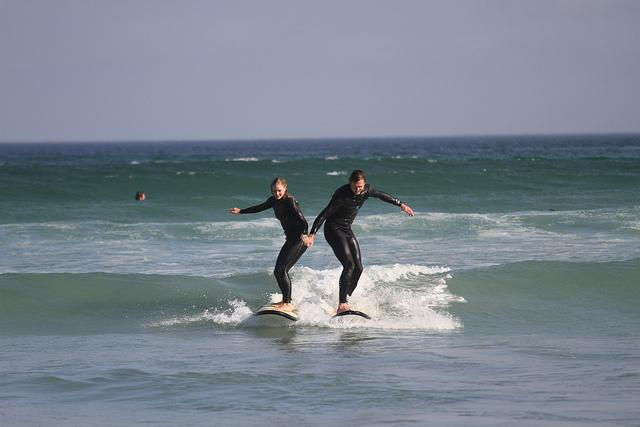How do these people know each other? Please explain your reasoning. spouses. These people might be spouses since they're vacationing together. 